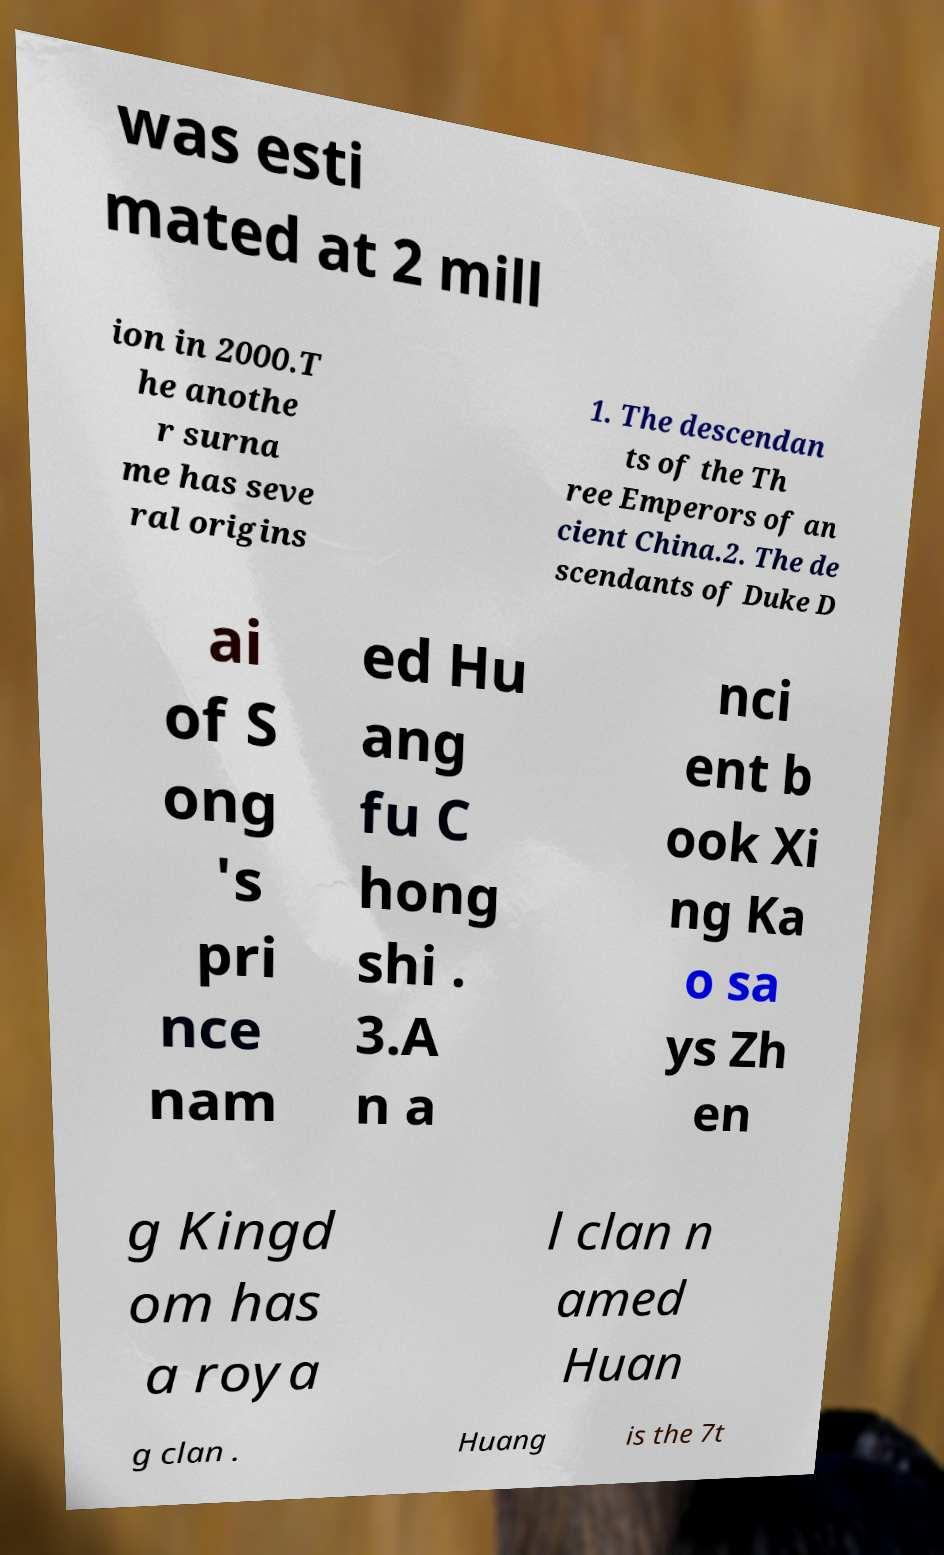Can you accurately transcribe the text from the provided image for me? was esti mated at 2 mill ion in 2000.T he anothe r surna me has seve ral origins 1. The descendan ts of the Th ree Emperors of an cient China.2. The de scendants of Duke D ai of S ong 's pri nce nam ed Hu ang fu C hong shi . 3.A n a nci ent b ook Xi ng Ka o sa ys Zh en g Kingd om has a roya l clan n amed Huan g clan . Huang is the 7t 